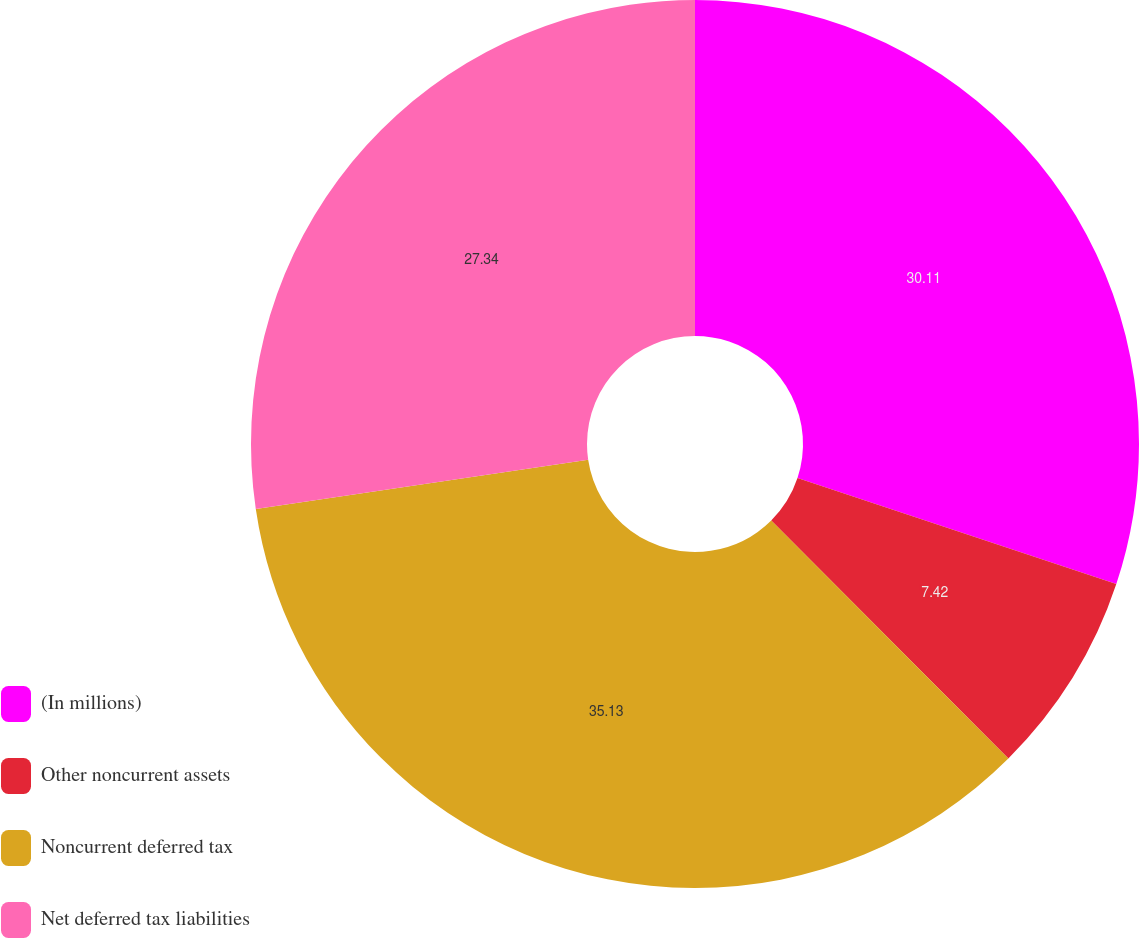<chart> <loc_0><loc_0><loc_500><loc_500><pie_chart><fcel>(In millions)<fcel>Other noncurrent assets<fcel>Noncurrent deferred tax<fcel>Net deferred tax liabilities<nl><fcel>30.11%<fcel>7.42%<fcel>35.13%<fcel>27.34%<nl></chart> 